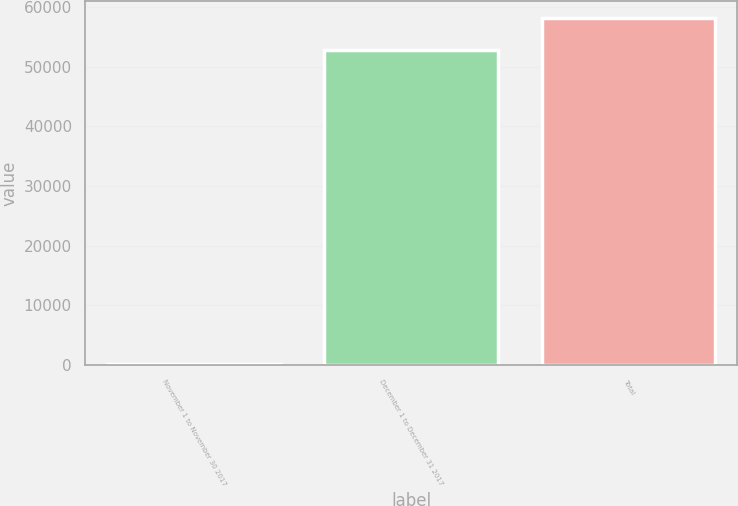Convert chart. <chart><loc_0><loc_0><loc_500><loc_500><bar_chart><fcel>November 1 to November 30 2017<fcel>December 1 to December 31 2017<fcel>Total<nl><fcel>145<fcel>52794<fcel>58073.4<nl></chart> 